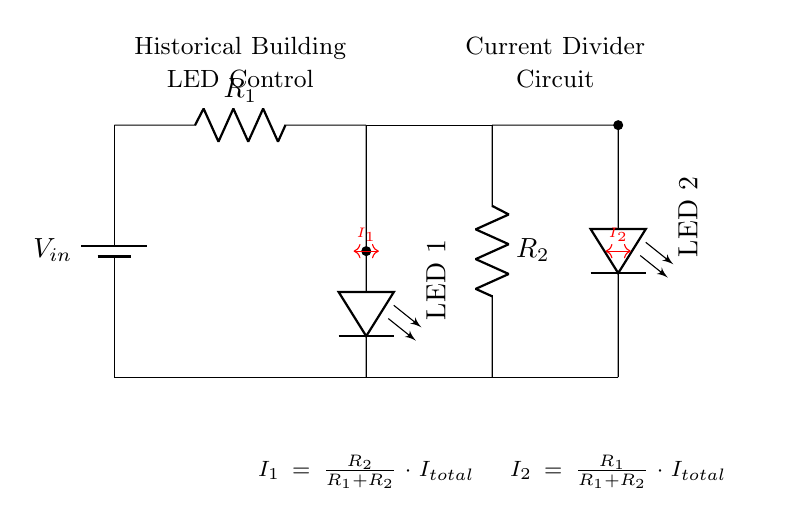What is the total voltage of the circuit? The total voltage of the circuit is indicated by the label near the battery, which represents the input voltage.
Answer: Vin What are the two resistors labeled in the circuit? The resistors are labeled as R1 and R2, which are essential components for the current division.
Answer: R1, R2 How many LEDs are shown in the circuit? There are two LEDs illustrated in the circuit diagram, reflecting the two paths for current flow.
Answer: 2 What is the formula for current I1? The formula for current I1 is given in the circuit: I1 equals the resistance R2 divided by the total resistance (R1 plus R2) multiplied by the total current.
Answer: I1 = R2 / (R1 + R2) * Itotal How does the current split between the LEDs? The current splits based on the resistance values of R1 and R2, where a larger resistance receives less current and vice versa, creating a divider effect.
Answer: Based on resistance values What will happen if R1 is increased? If R1 is increased, according to the current division principle, the current I1 will decrease while I2 will increase since the total current remains the same.
Answer: I1 decreases, I2 increases Which component causes the brightness difference in the LEDs? The brightness difference in the LEDs arises from the varying currents (I1 and I2) supplied to them, which depend on the resistances in the circuit.
Answer: Current (I1, I2) 